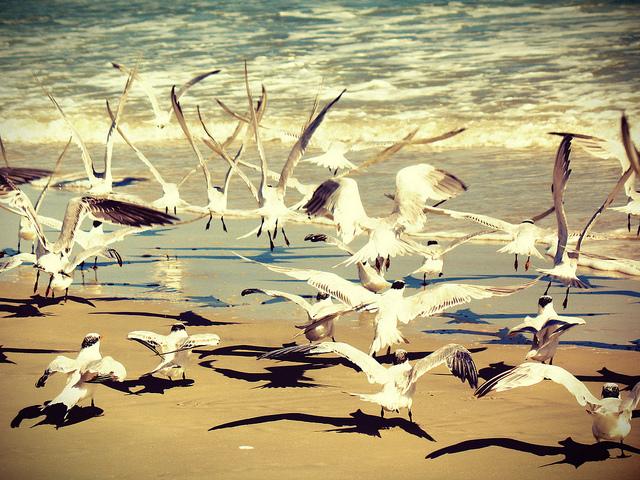What kind of bird is this?
Concise answer only. Seagull. Is there only one bird?
Write a very short answer. No. Is this outdoors?
Be succinct. Yes. 